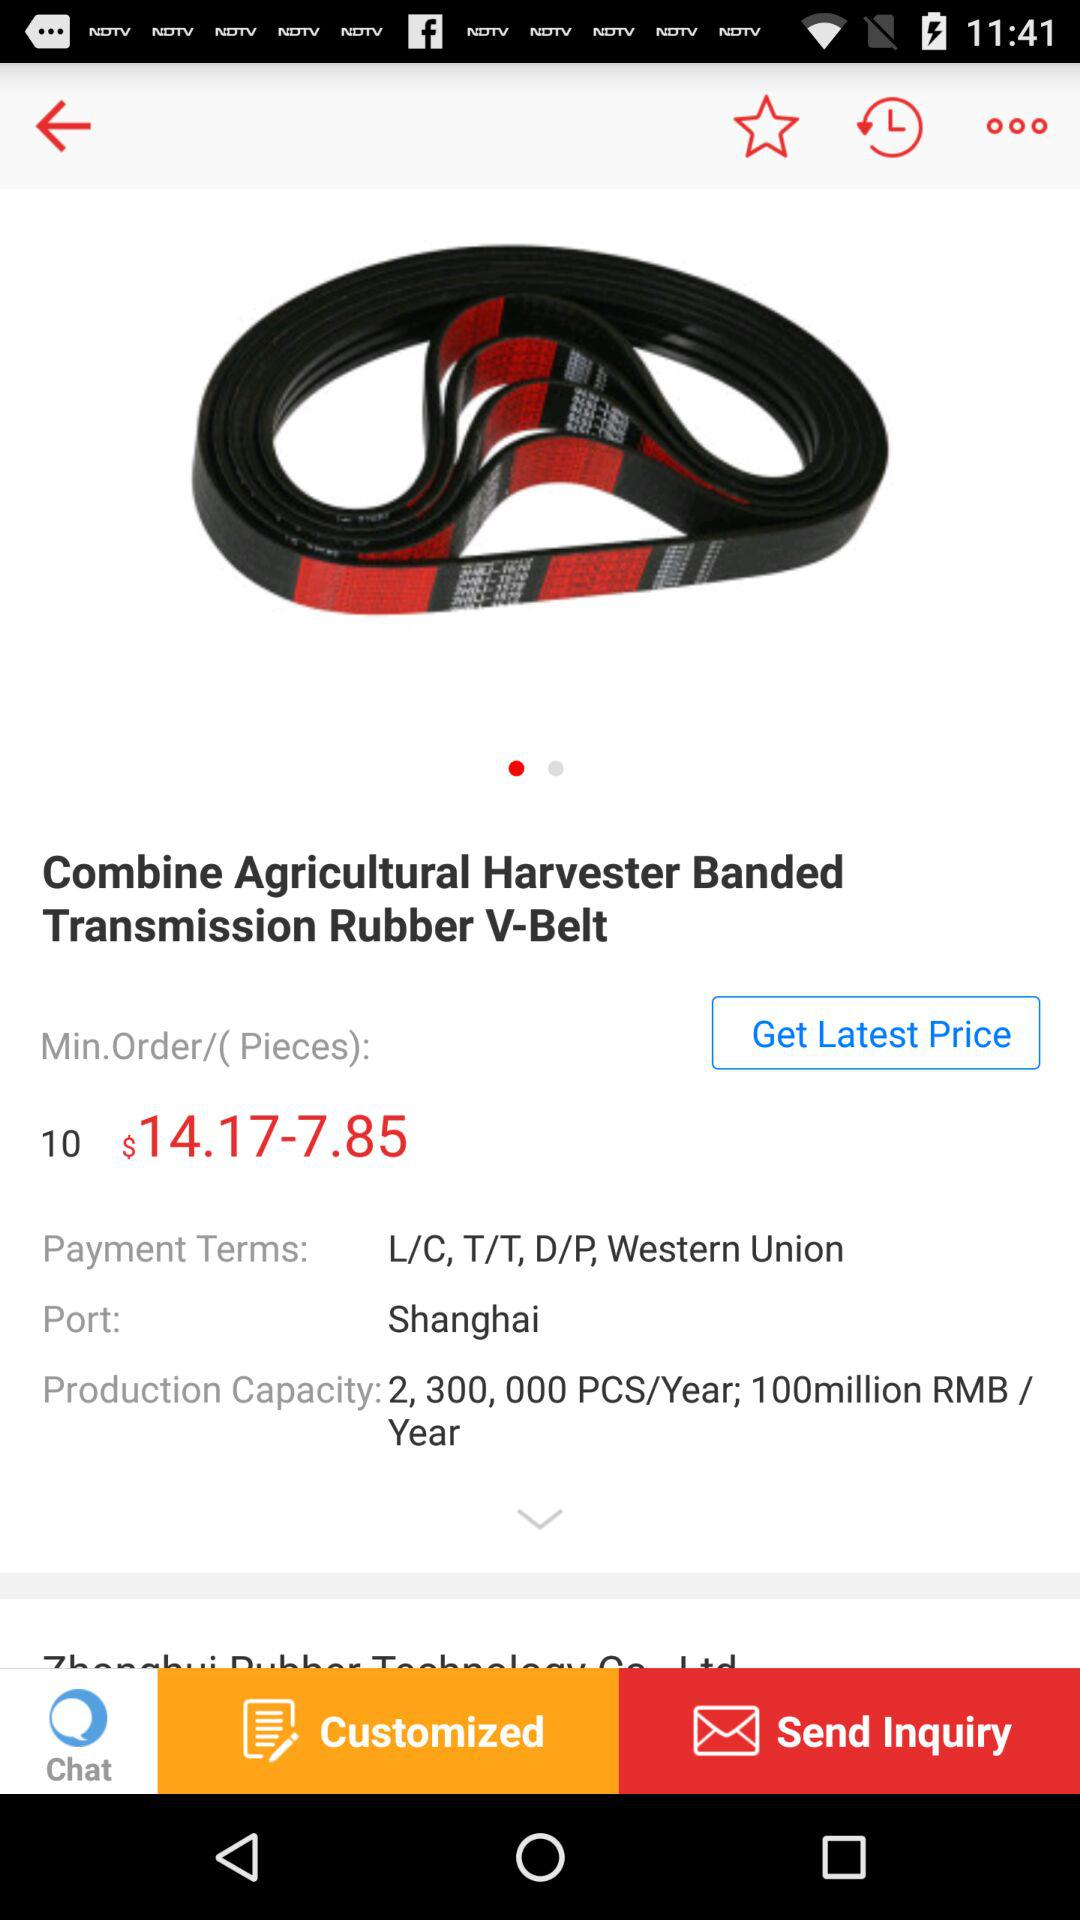What are the payment terms for the product?
Answer the question using a single word or phrase. L/C, T/T, D/P, Western Union 